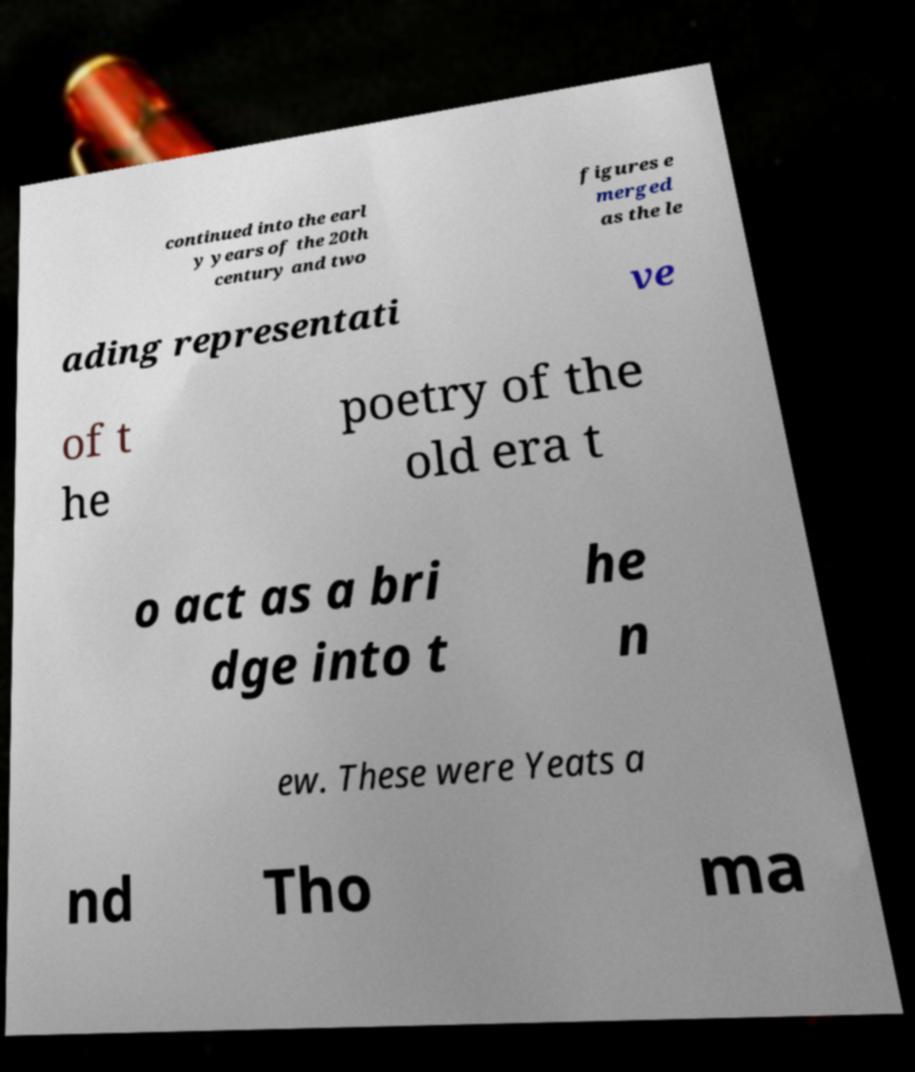I need the written content from this picture converted into text. Can you do that? continued into the earl y years of the 20th century and two figures e merged as the le ading representati ve of t he poetry of the old era t o act as a bri dge into t he n ew. These were Yeats a nd Tho ma 